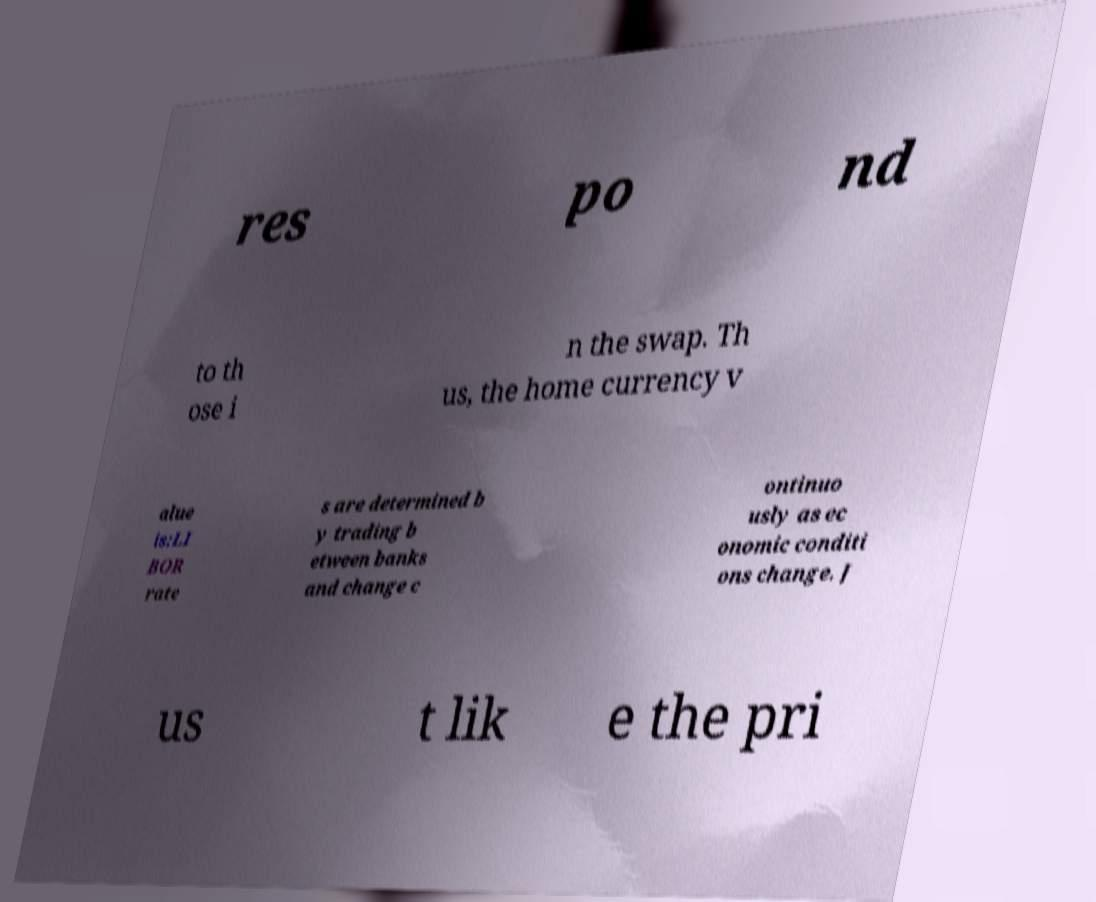What messages or text are displayed in this image? I need them in a readable, typed format. res po nd to th ose i n the swap. Th us, the home currency v alue is:LI BOR rate s are determined b y trading b etween banks and change c ontinuo usly as ec onomic conditi ons change. J us t lik e the pri 